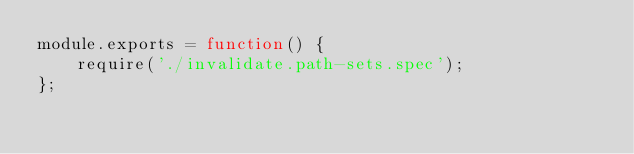Convert code to text. <code><loc_0><loc_0><loc_500><loc_500><_JavaScript_>module.exports = function() {
    require('./invalidate.path-sets.spec');
};</code> 